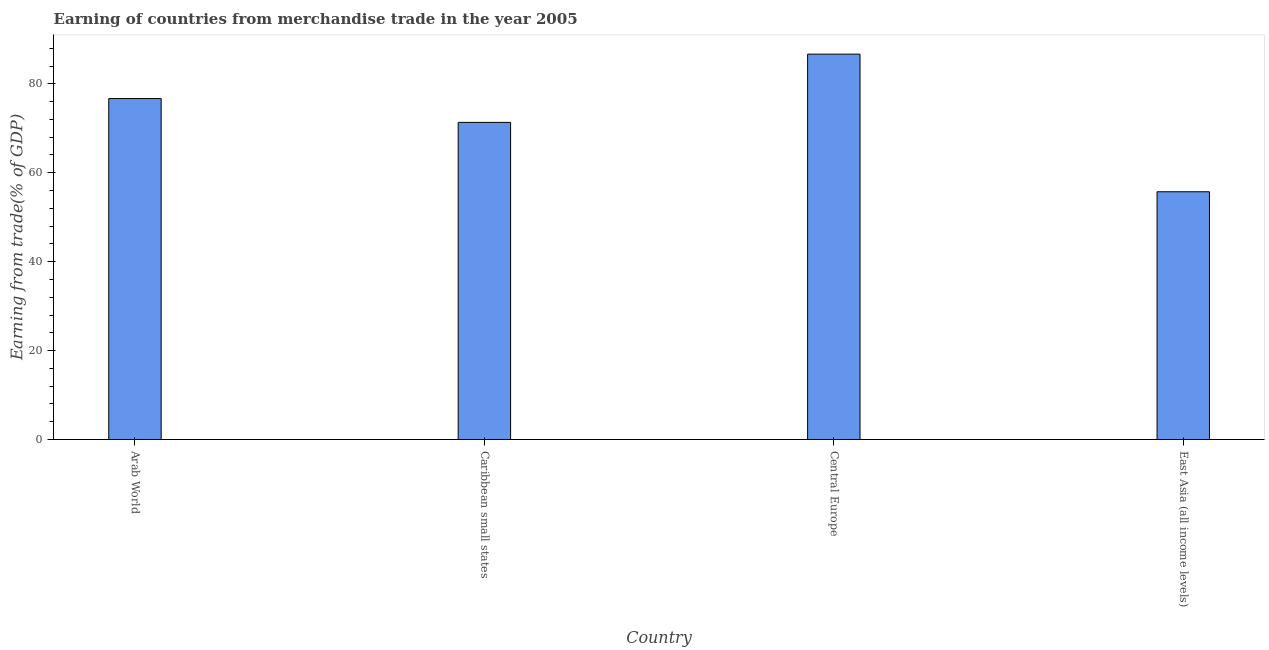What is the title of the graph?
Offer a terse response. Earning of countries from merchandise trade in the year 2005. What is the label or title of the Y-axis?
Offer a terse response. Earning from trade(% of GDP). What is the earning from merchandise trade in Caribbean small states?
Your answer should be very brief. 71.33. Across all countries, what is the maximum earning from merchandise trade?
Offer a very short reply. 86.67. Across all countries, what is the minimum earning from merchandise trade?
Provide a short and direct response. 55.72. In which country was the earning from merchandise trade maximum?
Offer a very short reply. Central Europe. In which country was the earning from merchandise trade minimum?
Offer a very short reply. East Asia (all income levels). What is the sum of the earning from merchandise trade?
Provide a succinct answer. 290.41. What is the difference between the earning from merchandise trade in Central Europe and East Asia (all income levels)?
Your answer should be very brief. 30.95. What is the average earning from merchandise trade per country?
Provide a succinct answer. 72.6. What is the median earning from merchandise trade?
Your response must be concise. 74.01. What is the ratio of the earning from merchandise trade in Arab World to that in Caribbean small states?
Keep it short and to the point. 1.07. Is the earning from merchandise trade in Arab World less than that in Central Europe?
Make the answer very short. Yes. What is the difference between the highest and the second highest earning from merchandise trade?
Your response must be concise. 9.99. What is the difference between the highest and the lowest earning from merchandise trade?
Provide a succinct answer. 30.95. In how many countries, is the earning from merchandise trade greater than the average earning from merchandise trade taken over all countries?
Your answer should be very brief. 2. How many bars are there?
Offer a terse response. 4. What is the Earning from trade(% of GDP) in Arab World?
Keep it short and to the point. 76.69. What is the Earning from trade(% of GDP) of Caribbean small states?
Ensure brevity in your answer.  71.33. What is the Earning from trade(% of GDP) of Central Europe?
Offer a very short reply. 86.67. What is the Earning from trade(% of GDP) of East Asia (all income levels)?
Give a very brief answer. 55.72. What is the difference between the Earning from trade(% of GDP) in Arab World and Caribbean small states?
Your response must be concise. 5.36. What is the difference between the Earning from trade(% of GDP) in Arab World and Central Europe?
Your response must be concise. -9.99. What is the difference between the Earning from trade(% of GDP) in Arab World and East Asia (all income levels)?
Give a very brief answer. 20.96. What is the difference between the Earning from trade(% of GDP) in Caribbean small states and Central Europe?
Your response must be concise. -15.35. What is the difference between the Earning from trade(% of GDP) in Caribbean small states and East Asia (all income levels)?
Ensure brevity in your answer.  15.6. What is the difference between the Earning from trade(% of GDP) in Central Europe and East Asia (all income levels)?
Ensure brevity in your answer.  30.95. What is the ratio of the Earning from trade(% of GDP) in Arab World to that in Caribbean small states?
Make the answer very short. 1.07. What is the ratio of the Earning from trade(% of GDP) in Arab World to that in Central Europe?
Provide a short and direct response. 0.89. What is the ratio of the Earning from trade(% of GDP) in Arab World to that in East Asia (all income levels)?
Provide a short and direct response. 1.38. What is the ratio of the Earning from trade(% of GDP) in Caribbean small states to that in Central Europe?
Provide a succinct answer. 0.82. What is the ratio of the Earning from trade(% of GDP) in Caribbean small states to that in East Asia (all income levels)?
Offer a very short reply. 1.28. What is the ratio of the Earning from trade(% of GDP) in Central Europe to that in East Asia (all income levels)?
Your answer should be compact. 1.55. 